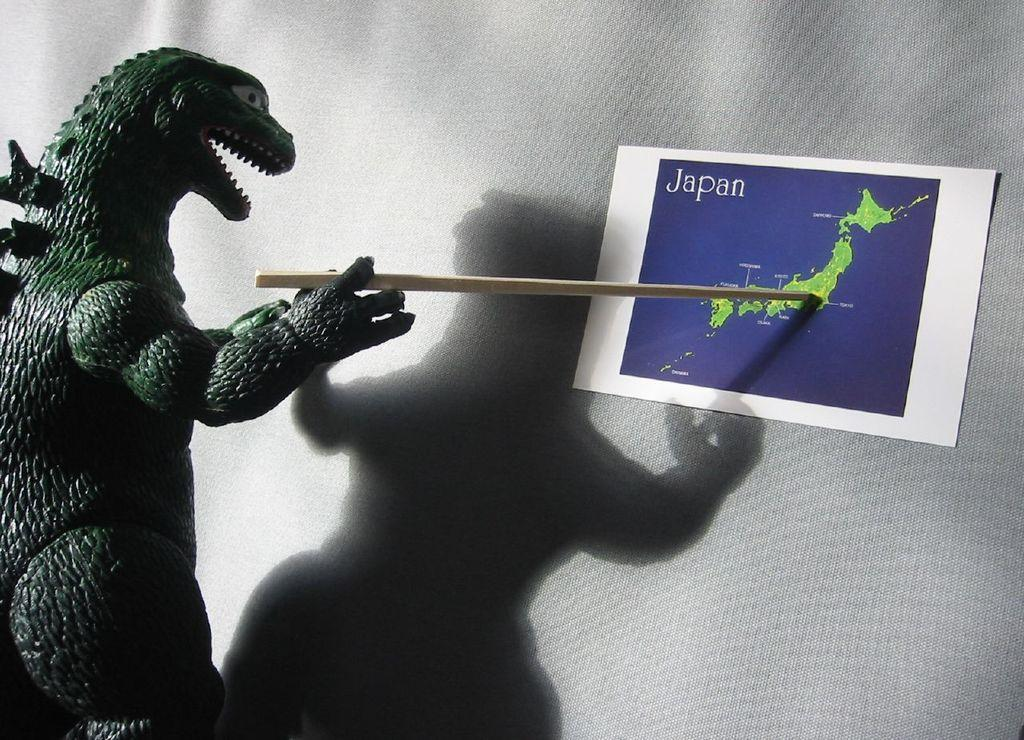What object is present in the image that resembles an animal? There is a toy animal in the image. What is the toy animal holding in its hands? The toy animal is holding a stick. What can be seen on the wall in the background of the image? There is a paper on the wall in the background of the image. What additional detail can be observed in the image? A shadow is visible in the image. How does the toy animal express its feelings in the image? The toy animal is not capable of expressing feelings, as it is an inanimate object. 